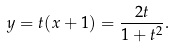Convert formula to latex. <formula><loc_0><loc_0><loc_500><loc_500>y = t ( x + 1 ) = { \frac { 2 t } { 1 + t ^ { 2 } } } .</formula> 